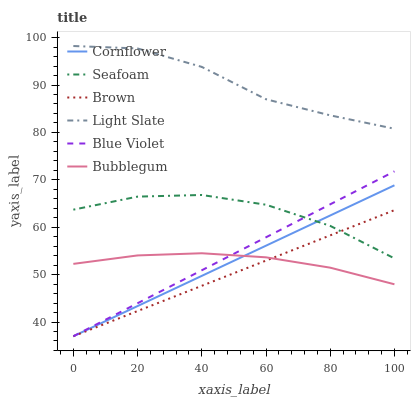Does Brown have the minimum area under the curve?
Answer yes or no. Yes. Does Light Slate have the maximum area under the curve?
Answer yes or no. Yes. Does Light Slate have the minimum area under the curve?
Answer yes or no. No. Does Brown have the maximum area under the curve?
Answer yes or no. No. Is Cornflower the smoothest?
Answer yes or no. Yes. Is Light Slate the roughest?
Answer yes or no. Yes. Is Brown the smoothest?
Answer yes or no. No. Is Brown the roughest?
Answer yes or no. No. Does Cornflower have the lowest value?
Answer yes or no. Yes. Does Light Slate have the lowest value?
Answer yes or no. No. Does Light Slate have the highest value?
Answer yes or no. Yes. Does Brown have the highest value?
Answer yes or no. No. Is Brown less than Light Slate?
Answer yes or no. Yes. Is Light Slate greater than Bubblegum?
Answer yes or no. Yes. Does Brown intersect Bubblegum?
Answer yes or no. Yes. Is Brown less than Bubblegum?
Answer yes or no. No. Is Brown greater than Bubblegum?
Answer yes or no. No. Does Brown intersect Light Slate?
Answer yes or no. No. 